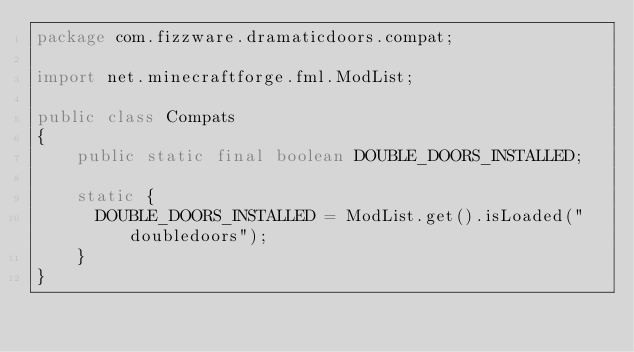<code> <loc_0><loc_0><loc_500><loc_500><_Java_>package com.fizzware.dramaticdoors.compat;

import net.minecraftforge.fml.ModList;

public class Compats
{
    public static final boolean DOUBLE_DOORS_INSTALLED;
    
    static {
    	DOUBLE_DOORS_INSTALLED = ModList.get().isLoaded("doubledoors");
    }
}
</code> 